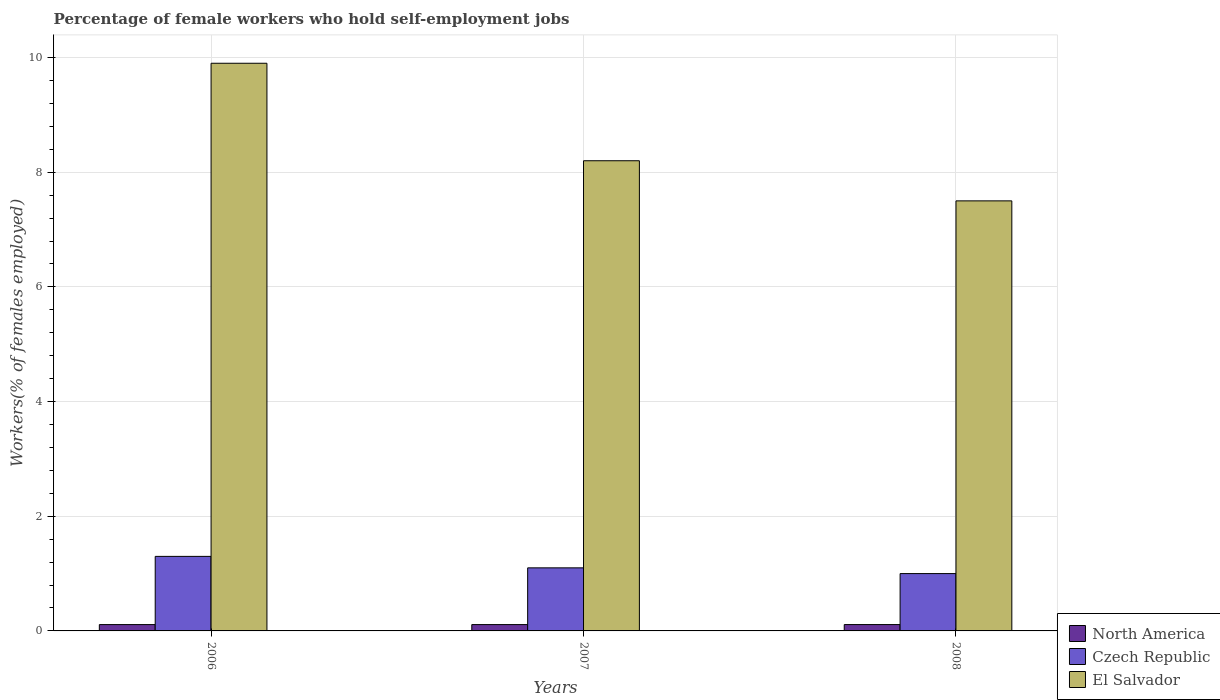How many different coloured bars are there?
Ensure brevity in your answer.  3. Are the number of bars on each tick of the X-axis equal?
Make the answer very short. Yes. How many bars are there on the 2nd tick from the left?
Offer a terse response. 3. In how many cases, is the number of bars for a given year not equal to the number of legend labels?
Give a very brief answer. 0. What is the percentage of self-employed female workers in El Salvador in 2006?
Ensure brevity in your answer.  9.9. Across all years, what is the maximum percentage of self-employed female workers in North America?
Ensure brevity in your answer.  0.11. What is the total percentage of self-employed female workers in Czech Republic in the graph?
Make the answer very short. 3.4. What is the difference between the percentage of self-employed female workers in Czech Republic in 2007 and that in 2008?
Offer a very short reply. 0.1. What is the difference between the percentage of self-employed female workers in Czech Republic in 2007 and the percentage of self-employed female workers in North America in 2006?
Offer a terse response. 0.99. What is the average percentage of self-employed female workers in North America per year?
Your answer should be compact. 0.11. In the year 2008, what is the difference between the percentage of self-employed female workers in Czech Republic and percentage of self-employed female workers in El Salvador?
Your answer should be compact. -6.5. What is the ratio of the percentage of self-employed female workers in El Salvador in 2007 to that in 2008?
Offer a terse response. 1.09. Is the difference between the percentage of self-employed female workers in Czech Republic in 2007 and 2008 greater than the difference between the percentage of self-employed female workers in El Salvador in 2007 and 2008?
Give a very brief answer. No. What is the difference between the highest and the second highest percentage of self-employed female workers in El Salvador?
Your response must be concise. 1.7. What is the difference between the highest and the lowest percentage of self-employed female workers in North America?
Provide a short and direct response. 0. What does the 1st bar from the left in 2008 represents?
Your answer should be compact. North America. How many bars are there?
Ensure brevity in your answer.  9. Are all the bars in the graph horizontal?
Your answer should be very brief. No. How many years are there in the graph?
Your response must be concise. 3. What is the difference between two consecutive major ticks on the Y-axis?
Give a very brief answer. 2. Does the graph contain any zero values?
Give a very brief answer. No. Where does the legend appear in the graph?
Make the answer very short. Bottom right. What is the title of the graph?
Ensure brevity in your answer.  Percentage of female workers who hold self-employment jobs. What is the label or title of the X-axis?
Your answer should be compact. Years. What is the label or title of the Y-axis?
Offer a terse response. Workers(% of females employed). What is the Workers(% of females employed) of North America in 2006?
Keep it short and to the point. 0.11. What is the Workers(% of females employed) in Czech Republic in 2006?
Offer a very short reply. 1.3. What is the Workers(% of females employed) of El Salvador in 2006?
Your answer should be very brief. 9.9. What is the Workers(% of females employed) in North America in 2007?
Ensure brevity in your answer.  0.11. What is the Workers(% of females employed) of Czech Republic in 2007?
Your answer should be very brief. 1.1. What is the Workers(% of females employed) in El Salvador in 2007?
Make the answer very short. 8.2. What is the Workers(% of females employed) of North America in 2008?
Your response must be concise. 0.11. Across all years, what is the maximum Workers(% of females employed) of North America?
Ensure brevity in your answer.  0.11. Across all years, what is the maximum Workers(% of females employed) of Czech Republic?
Your response must be concise. 1.3. Across all years, what is the maximum Workers(% of females employed) in El Salvador?
Keep it short and to the point. 9.9. Across all years, what is the minimum Workers(% of females employed) in North America?
Provide a succinct answer. 0.11. What is the total Workers(% of females employed) in North America in the graph?
Give a very brief answer. 0.33. What is the total Workers(% of females employed) in El Salvador in the graph?
Offer a very short reply. 25.6. What is the difference between the Workers(% of females employed) in North America in 2006 and that in 2007?
Offer a very short reply. -0. What is the difference between the Workers(% of females employed) in El Salvador in 2006 and that in 2007?
Your answer should be compact. 1.7. What is the difference between the Workers(% of females employed) of North America in 2006 and that in 2008?
Offer a very short reply. -0. What is the difference between the Workers(% of females employed) in Czech Republic in 2006 and that in 2008?
Offer a very short reply. 0.3. What is the difference between the Workers(% of females employed) in North America in 2007 and that in 2008?
Your answer should be compact. -0. What is the difference between the Workers(% of females employed) in Czech Republic in 2007 and that in 2008?
Make the answer very short. 0.1. What is the difference between the Workers(% of females employed) of North America in 2006 and the Workers(% of females employed) of Czech Republic in 2007?
Your response must be concise. -0.99. What is the difference between the Workers(% of females employed) in North America in 2006 and the Workers(% of females employed) in El Salvador in 2007?
Make the answer very short. -8.09. What is the difference between the Workers(% of females employed) in North America in 2006 and the Workers(% of females employed) in Czech Republic in 2008?
Offer a very short reply. -0.89. What is the difference between the Workers(% of females employed) in North America in 2006 and the Workers(% of females employed) in El Salvador in 2008?
Make the answer very short. -7.39. What is the difference between the Workers(% of females employed) of North America in 2007 and the Workers(% of females employed) of Czech Republic in 2008?
Your answer should be very brief. -0.89. What is the difference between the Workers(% of females employed) in North America in 2007 and the Workers(% of females employed) in El Salvador in 2008?
Offer a very short reply. -7.39. What is the average Workers(% of females employed) in North America per year?
Keep it short and to the point. 0.11. What is the average Workers(% of females employed) of Czech Republic per year?
Provide a succinct answer. 1.13. What is the average Workers(% of females employed) of El Salvador per year?
Give a very brief answer. 8.53. In the year 2006, what is the difference between the Workers(% of females employed) in North America and Workers(% of females employed) in Czech Republic?
Your answer should be compact. -1.19. In the year 2006, what is the difference between the Workers(% of females employed) of North America and Workers(% of females employed) of El Salvador?
Give a very brief answer. -9.79. In the year 2006, what is the difference between the Workers(% of females employed) of Czech Republic and Workers(% of females employed) of El Salvador?
Provide a short and direct response. -8.6. In the year 2007, what is the difference between the Workers(% of females employed) in North America and Workers(% of females employed) in Czech Republic?
Give a very brief answer. -0.99. In the year 2007, what is the difference between the Workers(% of females employed) of North America and Workers(% of females employed) of El Salvador?
Your response must be concise. -8.09. In the year 2007, what is the difference between the Workers(% of females employed) of Czech Republic and Workers(% of females employed) of El Salvador?
Provide a short and direct response. -7.1. In the year 2008, what is the difference between the Workers(% of females employed) of North America and Workers(% of females employed) of Czech Republic?
Provide a succinct answer. -0.89. In the year 2008, what is the difference between the Workers(% of females employed) of North America and Workers(% of females employed) of El Salvador?
Your response must be concise. -7.39. In the year 2008, what is the difference between the Workers(% of females employed) in Czech Republic and Workers(% of females employed) in El Salvador?
Your response must be concise. -6.5. What is the ratio of the Workers(% of females employed) of Czech Republic in 2006 to that in 2007?
Provide a succinct answer. 1.18. What is the ratio of the Workers(% of females employed) of El Salvador in 2006 to that in 2007?
Make the answer very short. 1.21. What is the ratio of the Workers(% of females employed) in North America in 2006 to that in 2008?
Your response must be concise. 1. What is the ratio of the Workers(% of females employed) in Czech Republic in 2006 to that in 2008?
Provide a short and direct response. 1.3. What is the ratio of the Workers(% of females employed) in El Salvador in 2006 to that in 2008?
Provide a short and direct response. 1.32. What is the ratio of the Workers(% of females employed) in El Salvador in 2007 to that in 2008?
Provide a short and direct response. 1.09. What is the difference between the highest and the lowest Workers(% of females employed) in Czech Republic?
Provide a short and direct response. 0.3. What is the difference between the highest and the lowest Workers(% of females employed) in El Salvador?
Provide a succinct answer. 2.4. 